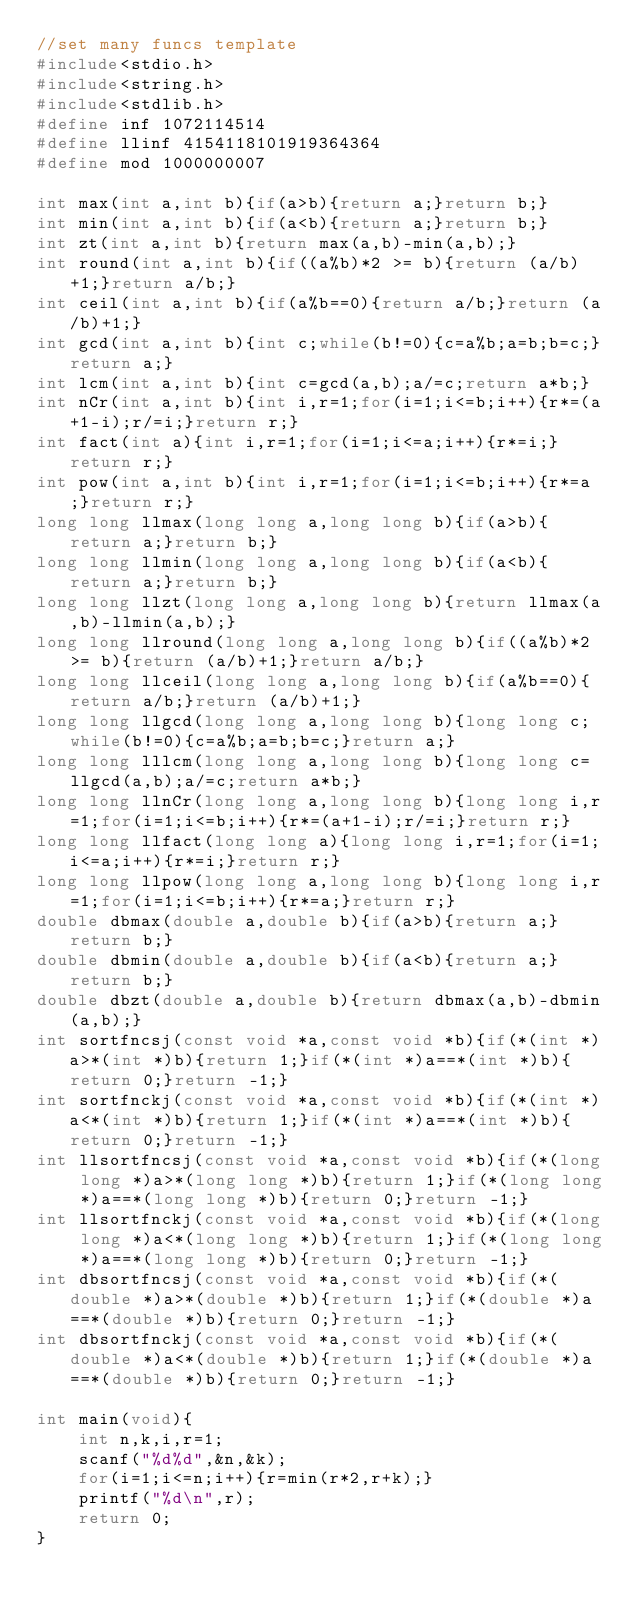Convert code to text. <code><loc_0><loc_0><loc_500><loc_500><_C_>//set many funcs template
#include<stdio.h>
#include<string.h>
#include<stdlib.h>
#define inf 1072114514
#define llinf 4154118101919364364
#define mod 1000000007
 
int max(int a,int b){if(a>b){return a;}return b;}
int min(int a,int b){if(a<b){return a;}return b;}
int zt(int a,int b){return max(a,b)-min(a,b);}
int round(int a,int b){if((a%b)*2 >= b){return (a/b)+1;}return a/b;}
int ceil(int a,int b){if(a%b==0){return a/b;}return (a/b)+1;}
int gcd(int a,int b){int c;while(b!=0){c=a%b;a=b;b=c;}return a;}
int lcm(int a,int b){int c=gcd(a,b);a/=c;return a*b;}
int nCr(int a,int b){int i,r=1;for(i=1;i<=b;i++){r*=(a+1-i);r/=i;}return r;}
int fact(int a){int i,r=1;for(i=1;i<=a;i++){r*=i;}return r;}
int pow(int a,int b){int i,r=1;for(i=1;i<=b;i++){r*=a;}return r;}
long long llmax(long long a,long long b){if(a>b){return a;}return b;}
long long llmin(long long a,long long b){if(a<b){return a;}return b;}
long long llzt(long long a,long long b){return llmax(a,b)-llmin(a,b);}
long long llround(long long a,long long b){if((a%b)*2 >= b){return (a/b)+1;}return a/b;}
long long llceil(long long a,long long b){if(a%b==0){return a/b;}return (a/b)+1;}
long long llgcd(long long a,long long b){long long c;while(b!=0){c=a%b;a=b;b=c;}return a;}
long long lllcm(long long a,long long b){long long c=llgcd(a,b);a/=c;return a*b;}
long long llnCr(long long a,long long b){long long i,r=1;for(i=1;i<=b;i++){r*=(a+1-i);r/=i;}return r;}
long long llfact(long long a){long long i,r=1;for(i=1;i<=a;i++){r*=i;}return r;}
long long llpow(long long a,long long b){long long i,r=1;for(i=1;i<=b;i++){r*=a;}return r;}
double dbmax(double a,double b){if(a>b){return a;}return b;}
double dbmin(double a,double b){if(a<b){return a;}return b;}
double dbzt(double a,double b){return dbmax(a,b)-dbmin(a,b);}
int sortfncsj(const void *a,const void *b){if(*(int *)a>*(int *)b){return 1;}if(*(int *)a==*(int *)b){return 0;}return -1;}
int sortfnckj(const void *a,const void *b){if(*(int *)a<*(int *)b){return 1;}if(*(int *)a==*(int *)b){return 0;}return -1;}
int llsortfncsj(const void *a,const void *b){if(*(long long *)a>*(long long *)b){return 1;}if(*(long long *)a==*(long long *)b){return 0;}return -1;}
int llsortfnckj(const void *a,const void *b){if(*(long long *)a<*(long long *)b){return 1;}if(*(long long *)a==*(long long *)b){return 0;}return -1;}
int dbsortfncsj(const void *a,const void *b){if(*(double *)a>*(double *)b){return 1;}if(*(double *)a==*(double *)b){return 0;}return -1;}
int dbsortfnckj(const void *a,const void *b){if(*(double *)a<*(double *)b){return 1;}if(*(double *)a==*(double *)b){return 0;}return -1;}
 
int main(void){
    int n,k,i,r=1;
    scanf("%d%d",&n,&k);
    for(i=1;i<=n;i++){r=min(r*2,r+k);}
    printf("%d\n",r);
    return 0;
}</code> 